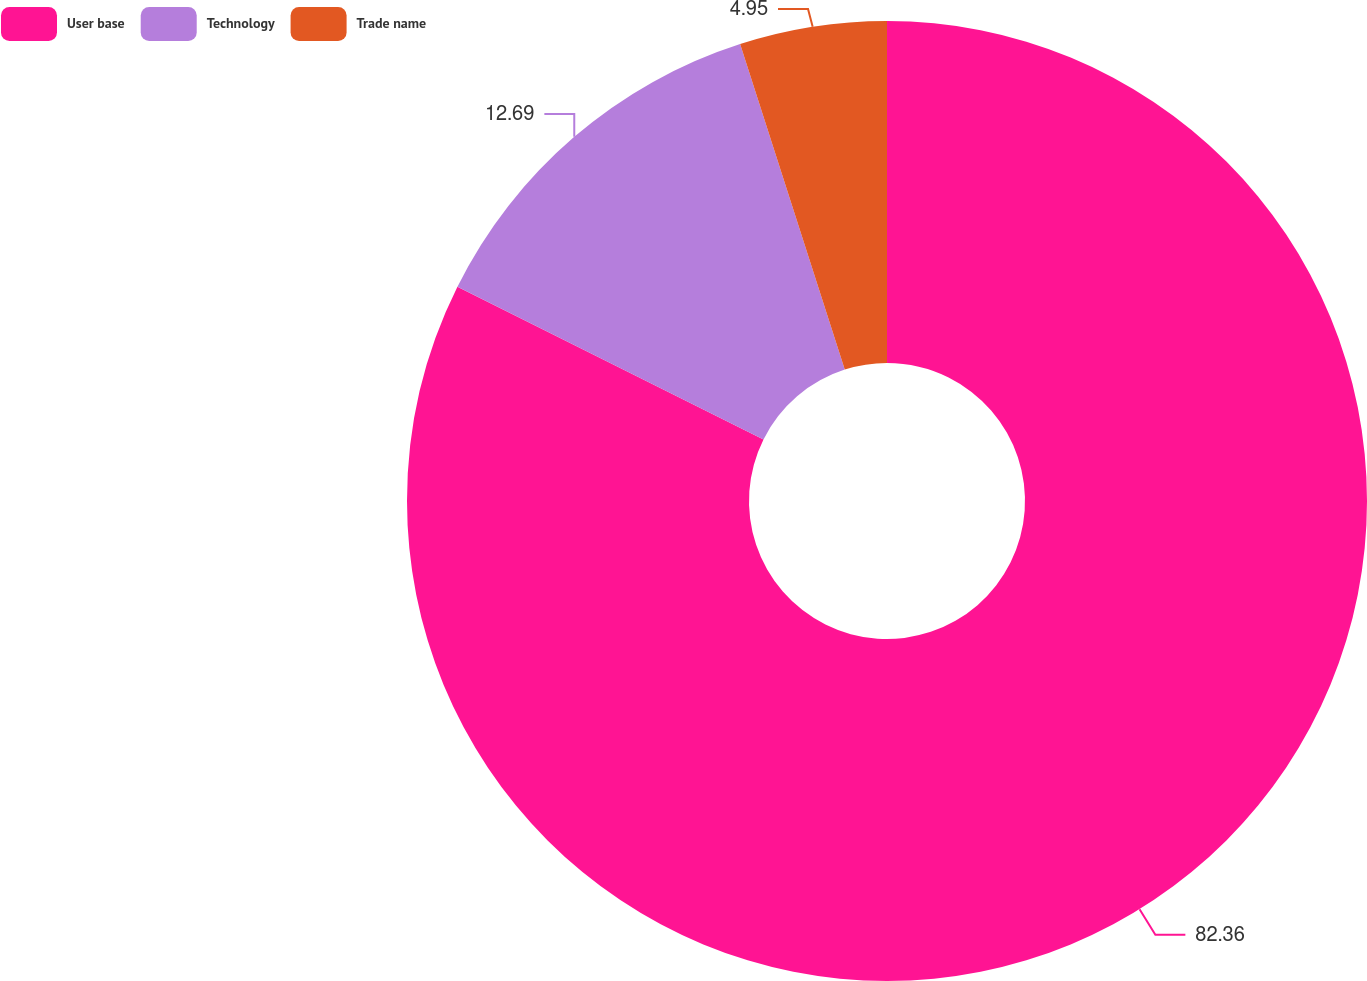Convert chart to OTSL. <chart><loc_0><loc_0><loc_500><loc_500><pie_chart><fcel>User base<fcel>Technology<fcel>Trade name<nl><fcel>82.37%<fcel>12.69%<fcel>4.95%<nl></chart> 